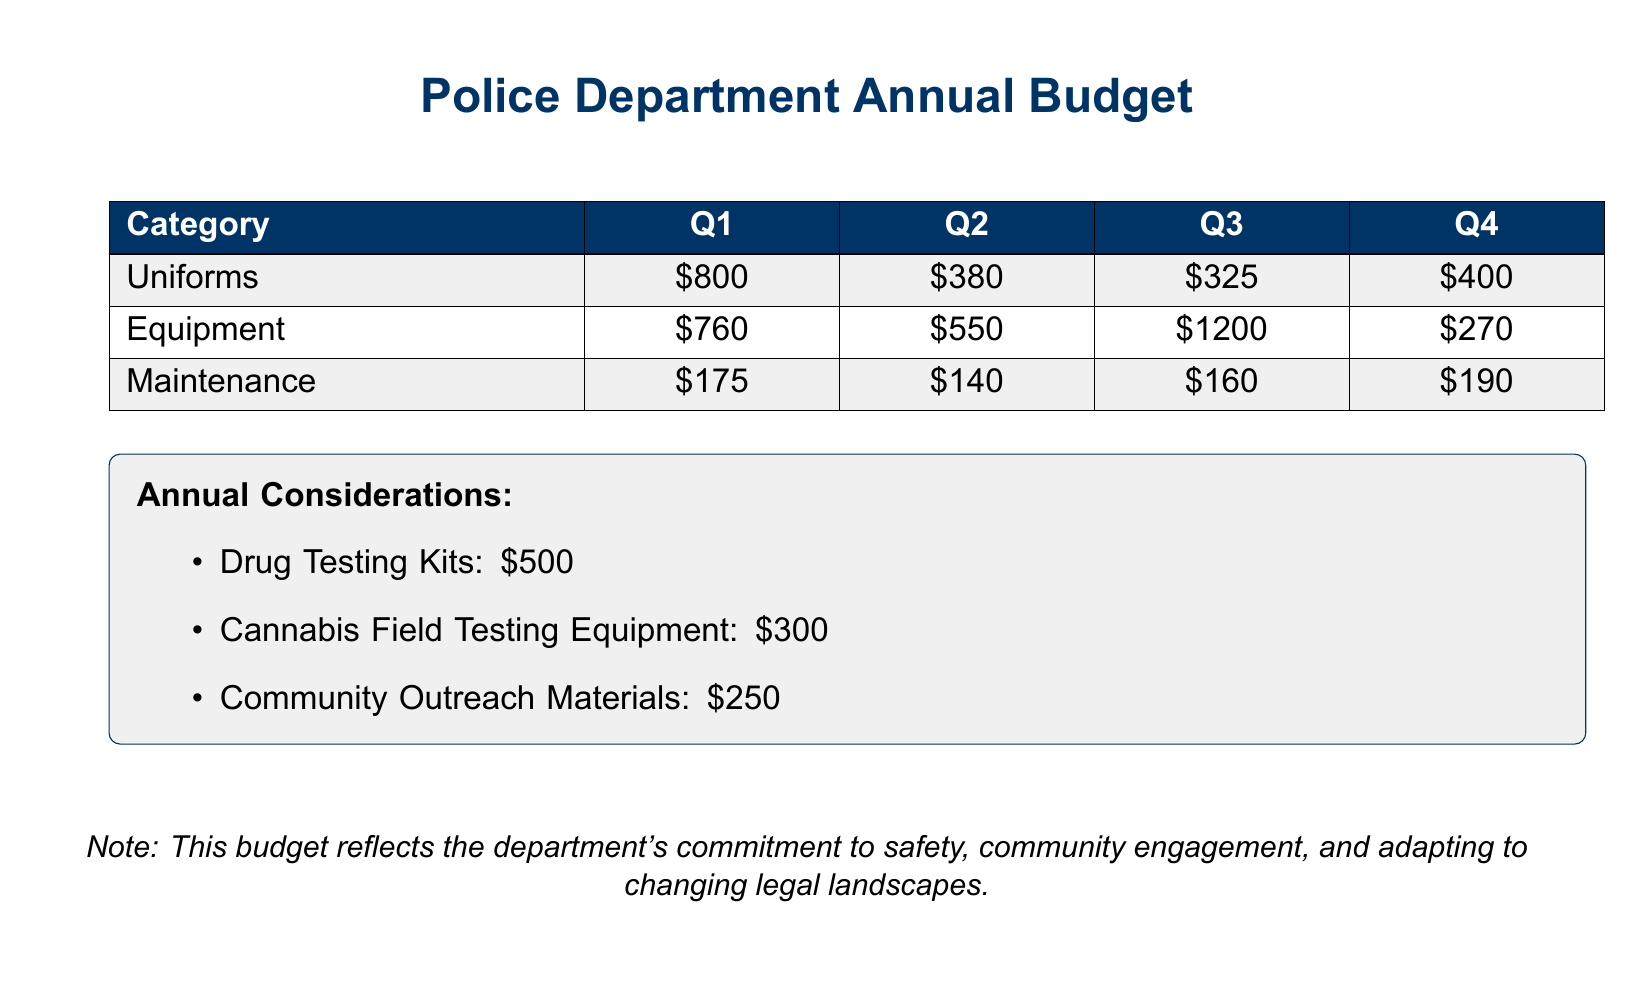What is the total budget for uniforms in Q1? The total budget for uniforms in Q1 is stated in the table under the Uniforms category for Q1.
Answer: $800 How much did the police department spend on equipment in Q3? The spending on equipment for Q3 can be found in the budget table under Equipment for Q3.
Answer: $1200 What is the combined total expense for maintenance over the four quarters? To find the combined total expense for maintenance, add all the maintenance costs across the quarters.
Answer: $665 What category had the lowest expense in Q2? The category with the lowest expense in Q2 can be determined by comparing the expenses listed in the table for each category.
Answer: Uniforms How much was allocated for drug testing kits in the annual considerations? The amount allocated for drug testing kits is specifically mentioned in the annual considerations section of the document.
Answer: $500 What percentage of the total quarterly maintenance expense comes from Q1? To find this percentage, divide the Q1 maintenance expense by the total maintenance expense for all quarters and multiply by 100.
Answer: 26.3% How much more was spent on equipment in Q3 compared to Q4? The difference in spending can be calculated by subtracting the Q4 equipment expense from the Q3 equipment expense.
Answer: $930 What is the total cost of community outreach materials? The total cost of community outreach materials is explicitly mentioned in the annual considerations section.
Answer: $250 Which quarter had the highest expenditure on uniforms? By examining the table, determine which quarter had the highest expenditure listed in the Uniforms category.
Answer: Q1 